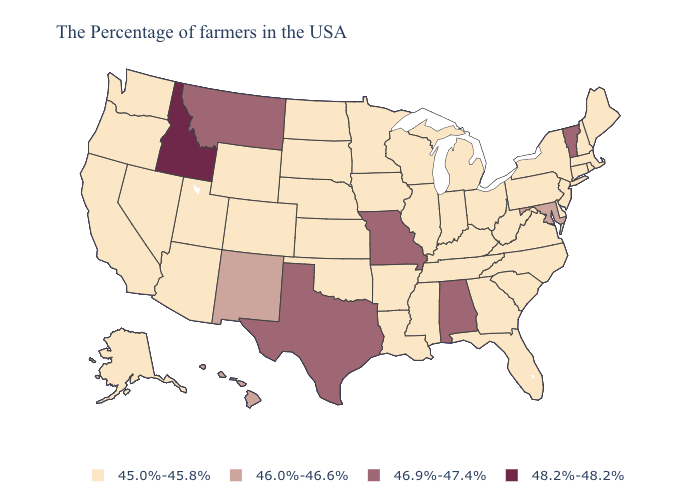Which states have the highest value in the USA?
Give a very brief answer. Idaho. Does the map have missing data?
Be succinct. No. Name the states that have a value in the range 46.9%-47.4%?
Short answer required. Vermont, Alabama, Missouri, Texas, Montana. What is the value of Florida?
Keep it brief. 45.0%-45.8%. What is the lowest value in the USA?
Quick response, please. 45.0%-45.8%. Does North Dakota have a lower value than Hawaii?
Quick response, please. Yes. What is the value of New Jersey?
Write a very short answer. 45.0%-45.8%. What is the lowest value in states that border Montana?
Short answer required. 45.0%-45.8%. Does the first symbol in the legend represent the smallest category?
Answer briefly. Yes. What is the value of South Dakota?
Give a very brief answer. 45.0%-45.8%. What is the highest value in the Northeast ?
Quick response, please. 46.9%-47.4%. What is the highest value in states that border Maryland?
Write a very short answer. 45.0%-45.8%. Name the states that have a value in the range 48.2%-48.2%?
Short answer required. Idaho. What is the highest value in the West ?
Concise answer only. 48.2%-48.2%. Name the states that have a value in the range 46.9%-47.4%?
Give a very brief answer. Vermont, Alabama, Missouri, Texas, Montana. 